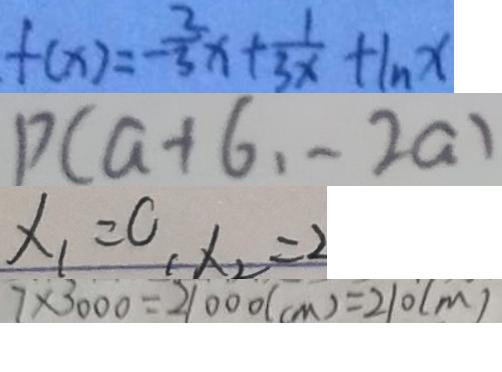<formula> <loc_0><loc_0><loc_500><loc_500>f ( x ) = - \frac { 2 } { 3 } x + \frac { 1 } { 3 x } + \ln x 
 P ( a + 6 , - 2 a ) 
 x _ { 1 } = 0 , x _ { 2 } = 2 
 7 \times 3 0 0 0 = 2 1 0 0 0 ( c m ) = 2 1 0 ( m )</formula> 